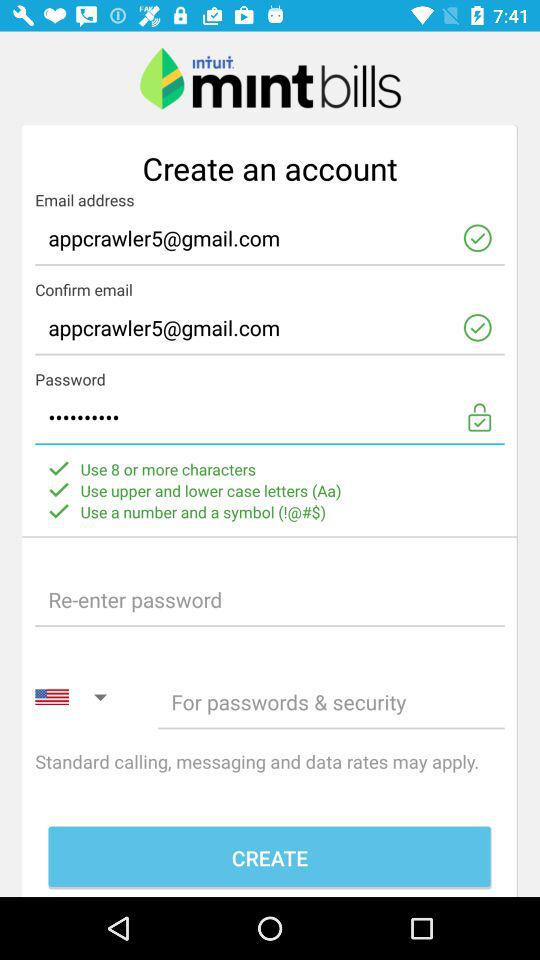What is the email address? The email address is appcrawler5@gmail.com. 